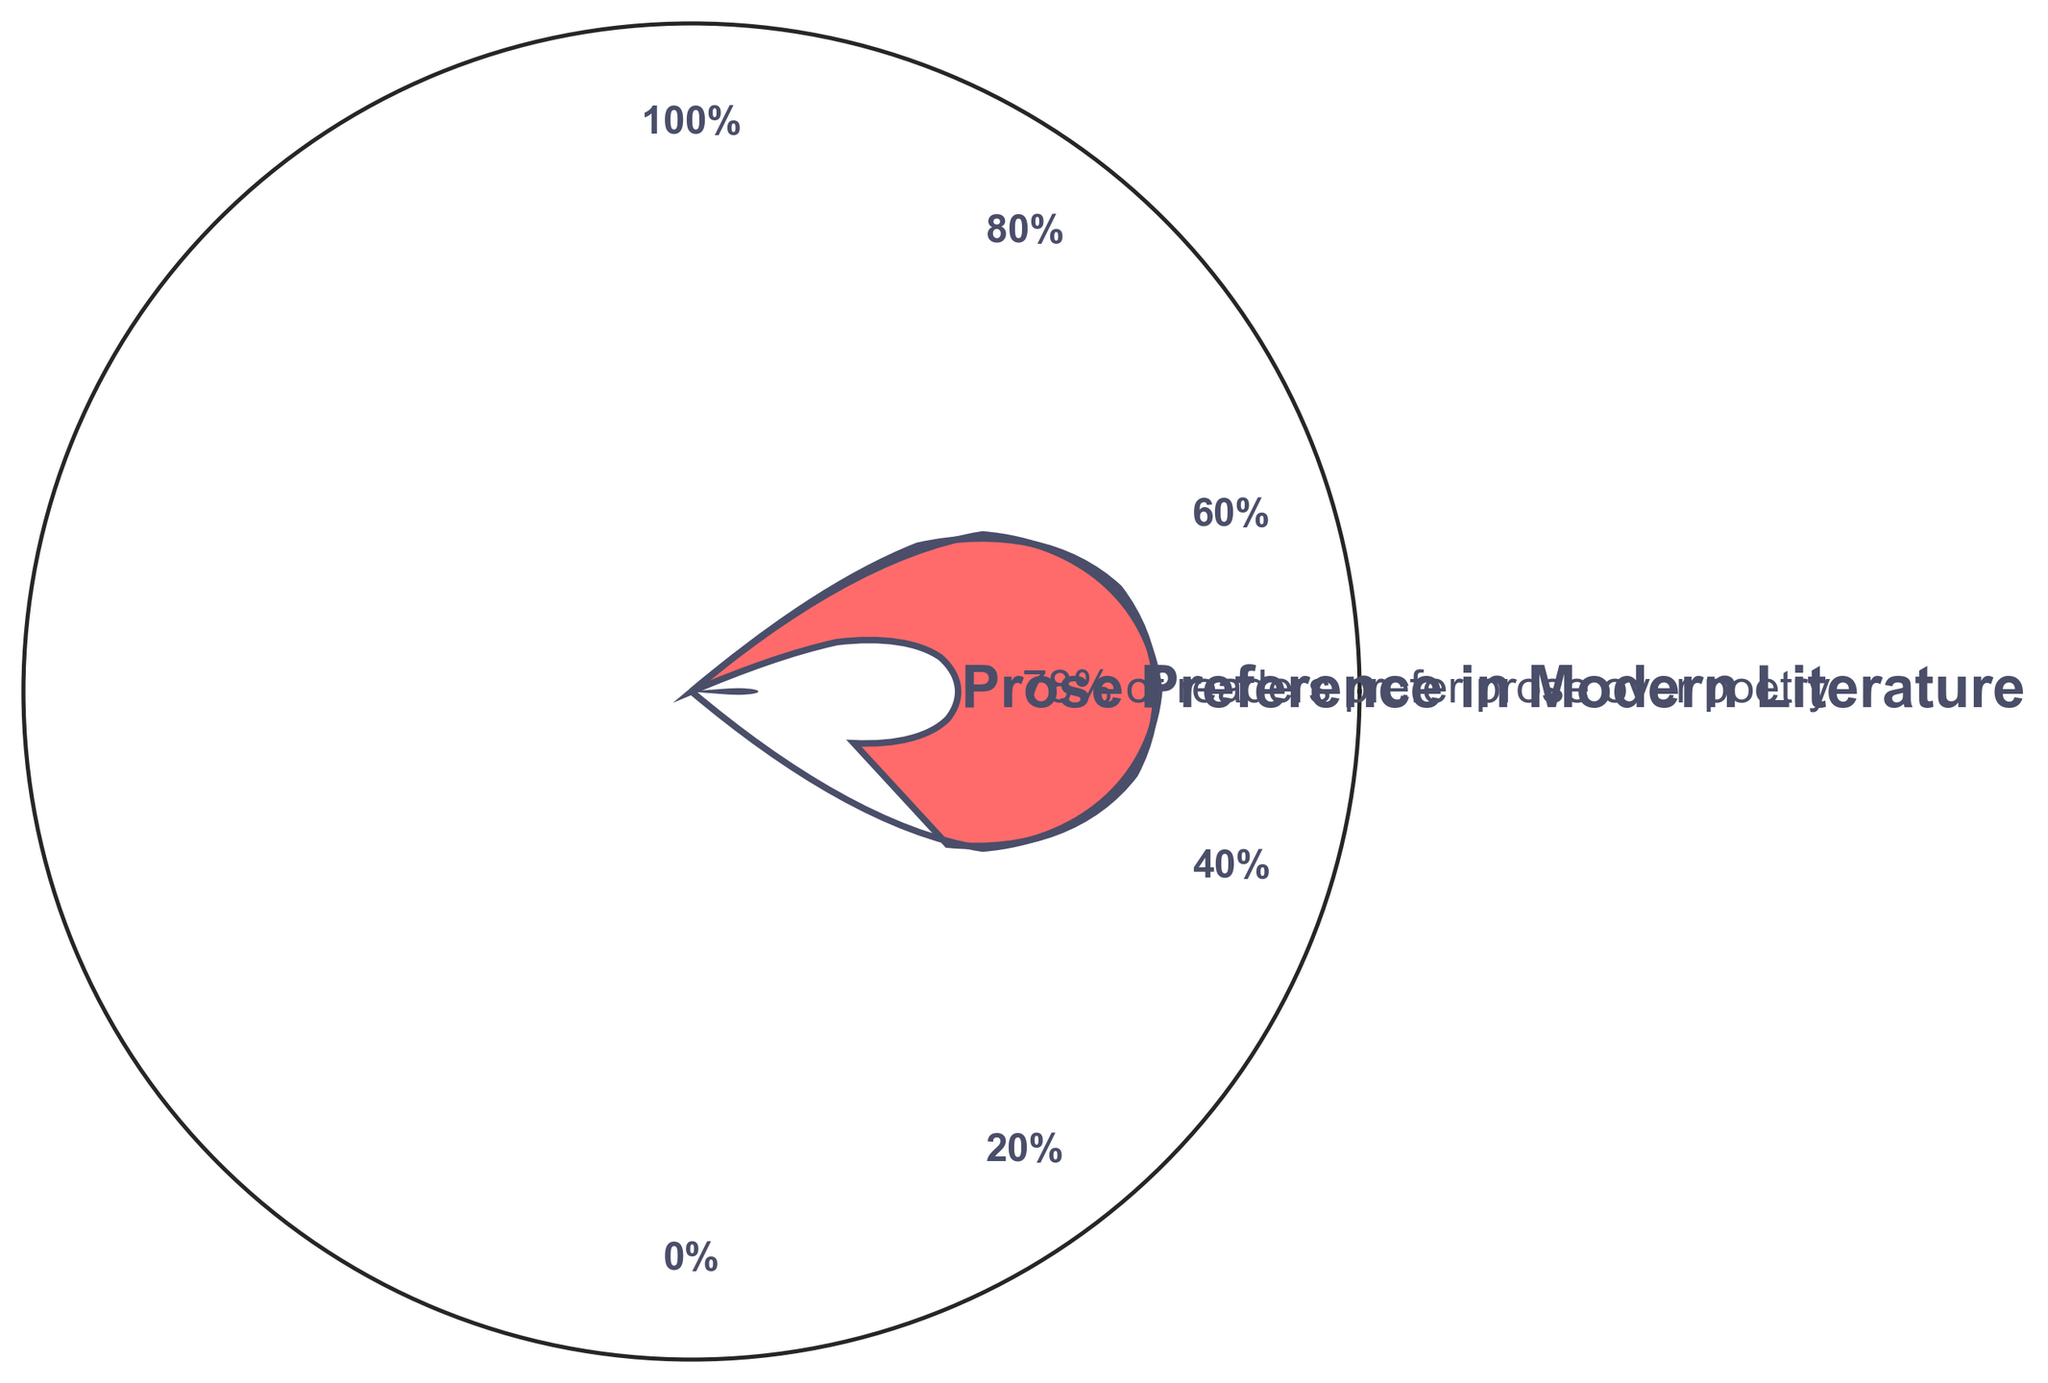What's the percentage of readers who prefer prose over poetry? The figure's title and the annotation beneath it explicitly state that 78% of readers prefer prose over poetry.
Answer: 78% What color represents the readers' preference for prose in the gauge chart? The gauge segment representing prose preference is shaded in a red color.
Answer: Red Is there any indication of neutrality among readers in their preference for prose or poetry? The figure mentions that 0% of readers are neutral, indicating no neutrality.
Answer: No What is the title of the figure? The title of the figure is prominently displayed above the gauge: "Prose Preference in Modern Literature."
Answer: Prose Preference in Modern Literature How many readers prefer poetry over prose according to the gauge? The figure annotation shows that 22% of readers prefer poetry over prose.
Answer: 22% What is the subtitle mentioned below the title of the gauge chart? The subtitle states: "78% of readers prefer prose over poetry."
Answer: 78% of readers prefer prose over poetry Which literary format does the footer of the figure suggest is not viable in the modern era? The footer mentions that poetry is not a viable literary format in the modern era.
Answer: Poetry If 100 represents the total percentage, what is the remaining percentage after accounting for prose and poetry preference? Prose preference is 78% and poetry preference is 22%. The sum is 78% + 22% = 100%, and thus the remaining percentage is 0%.
Answer: 0% How is the needle positioned in relation to the gauge scale? The needle is positioned pointing towards the 78% mark on the gauge scale.
Answer: Pointing at the 78% mark What is the angle in degrees indicated by the gauge segment for prose preference? Since the prose preference is 78%, it corresponds to an angle of (78/100) * 180 degrees = 140.4 degrees.
Answer: 140.4 degrees 